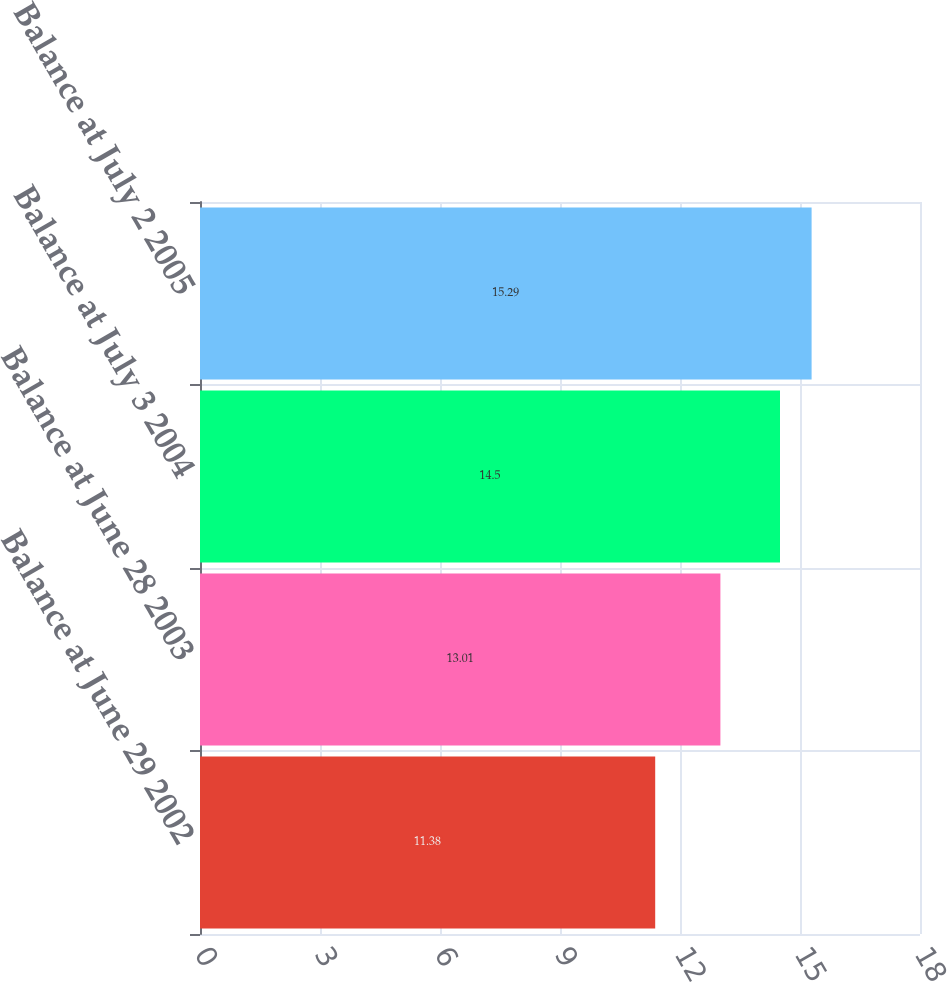<chart> <loc_0><loc_0><loc_500><loc_500><bar_chart><fcel>Balance at June 29 2002<fcel>Balance at June 28 2003<fcel>Balance at July 3 2004<fcel>Balance at July 2 2005<nl><fcel>11.38<fcel>13.01<fcel>14.5<fcel>15.29<nl></chart> 